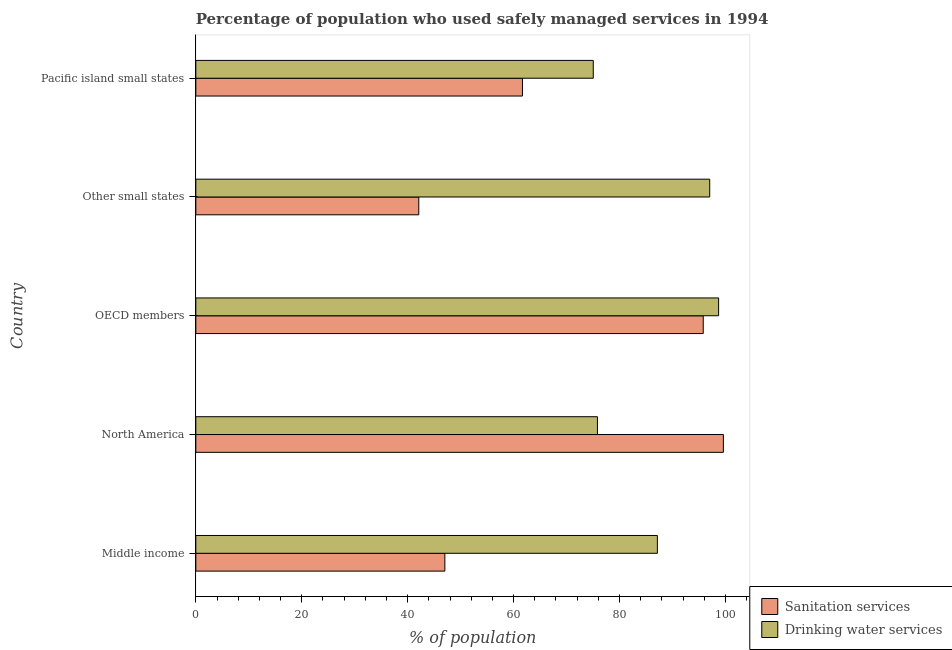How many different coloured bars are there?
Offer a very short reply. 2. How many groups of bars are there?
Your answer should be compact. 5. How many bars are there on the 2nd tick from the top?
Provide a short and direct response. 2. How many bars are there on the 3rd tick from the bottom?
Give a very brief answer. 2. What is the label of the 4th group of bars from the top?
Your response must be concise. North America. What is the percentage of population who used sanitation services in Middle income?
Your response must be concise. 47.03. Across all countries, what is the maximum percentage of population who used drinking water services?
Offer a terse response. 98.72. Across all countries, what is the minimum percentage of population who used drinking water services?
Keep it short and to the point. 75.05. In which country was the percentage of population who used drinking water services maximum?
Your answer should be compact. OECD members. In which country was the percentage of population who used drinking water services minimum?
Your answer should be compact. Pacific island small states. What is the total percentage of population who used drinking water services in the graph?
Ensure brevity in your answer.  433.8. What is the difference between the percentage of population who used drinking water services in North America and that in Other small states?
Your answer should be compact. -21.2. What is the difference between the percentage of population who used sanitation services in Middle income and the percentage of population who used drinking water services in North America?
Keep it short and to the point. -28.81. What is the average percentage of population who used drinking water services per country?
Provide a short and direct response. 86.76. What is the difference between the percentage of population who used sanitation services and percentage of population who used drinking water services in Pacific island small states?
Provide a short and direct response. -13.37. In how many countries, is the percentage of population who used drinking water services greater than 64 %?
Keep it short and to the point. 5. What is the ratio of the percentage of population who used sanitation services in Middle income to that in OECD members?
Your response must be concise. 0.49. What is the difference between the highest and the second highest percentage of population who used drinking water services?
Ensure brevity in your answer.  1.68. What is the difference between the highest and the lowest percentage of population who used sanitation services?
Your answer should be very brief. 57.52. In how many countries, is the percentage of population who used drinking water services greater than the average percentage of population who used drinking water services taken over all countries?
Your answer should be very brief. 3. What does the 1st bar from the top in OECD members represents?
Keep it short and to the point. Drinking water services. What does the 1st bar from the bottom in Middle income represents?
Give a very brief answer. Sanitation services. How many countries are there in the graph?
Give a very brief answer. 5. What is the difference between two consecutive major ticks on the X-axis?
Provide a succinct answer. 20. Are the values on the major ticks of X-axis written in scientific E-notation?
Your answer should be very brief. No. Does the graph contain any zero values?
Give a very brief answer. No. Does the graph contain grids?
Your response must be concise. No. Where does the legend appear in the graph?
Provide a short and direct response. Bottom right. How many legend labels are there?
Give a very brief answer. 2. What is the title of the graph?
Your answer should be compact. Percentage of population who used safely managed services in 1994. Does "Female" appear as one of the legend labels in the graph?
Your answer should be very brief. No. What is the label or title of the X-axis?
Provide a succinct answer. % of population. What is the label or title of the Y-axis?
Your answer should be very brief. Country. What is the % of population of Sanitation services in Middle income?
Your answer should be compact. 47.03. What is the % of population in Drinking water services in Middle income?
Keep it short and to the point. 87.16. What is the % of population in Sanitation services in North America?
Provide a succinct answer. 99.62. What is the % of population in Drinking water services in North America?
Your answer should be compact. 75.84. What is the % of population in Sanitation services in OECD members?
Provide a short and direct response. 95.82. What is the % of population of Drinking water services in OECD members?
Give a very brief answer. 98.72. What is the % of population of Sanitation services in Other small states?
Your answer should be compact. 42.1. What is the % of population of Drinking water services in Other small states?
Your response must be concise. 97.04. What is the % of population in Sanitation services in Pacific island small states?
Give a very brief answer. 61.68. What is the % of population of Drinking water services in Pacific island small states?
Your answer should be compact. 75.05. Across all countries, what is the maximum % of population in Sanitation services?
Give a very brief answer. 99.62. Across all countries, what is the maximum % of population of Drinking water services?
Offer a very short reply. 98.72. Across all countries, what is the minimum % of population of Sanitation services?
Ensure brevity in your answer.  42.1. Across all countries, what is the minimum % of population in Drinking water services?
Make the answer very short. 75.05. What is the total % of population of Sanitation services in the graph?
Provide a succinct answer. 346.24. What is the total % of population in Drinking water services in the graph?
Provide a short and direct response. 433.8. What is the difference between the % of population in Sanitation services in Middle income and that in North America?
Your answer should be compact. -52.59. What is the difference between the % of population of Drinking water services in Middle income and that in North America?
Your response must be concise. 11.32. What is the difference between the % of population in Sanitation services in Middle income and that in OECD members?
Give a very brief answer. -48.79. What is the difference between the % of population in Drinking water services in Middle income and that in OECD members?
Your answer should be compact. -11.56. What is the difference between the % of population of Sanitation services in Middle income and that in Other small states?
Keep it short and to the point. 4.93. What is the difference between the % of population in Drinking water services in Middle income and that in Other small states?
Your answer should be very brief. -9.88. What is the difference between the % of population in Sanitation services in Middle income and that in Pacific island small states?
Make the answer very short. -14.65. What is the difference between the % of population of Drinking water services in Middle income and that in Pacific island small states?
Make the answer very short. 12.11. What is the difference between the % of population in Sanitation services in North America and that in OECD members?
Give a very brief answer. 3.8. What is the difference between the % of population in Drinking water services in North America and that in OECD members?
Make the answer very short. -22.88. What is the difference between the % of population of Sanitation services in North America and that in Other small states?
Make the answer very short. 57.52. What is the difference between the % of population in Drinking water services in North America and that in Other small states?
Offer a terse response. -21.2. What is the difference between the % of population in Sanitation services in North America and that in Pacific island small states?
Make the answer very short. 37.94. What is the difference between the % of population of Drinking water services in North America and that in Pacific island small states?
Your response must be concise. 0.79. What is the difference between the % of population in Sanitation services in OECD members and that in Other small states?
Offer a terse response. 53.72. What is the difference between the % of population of Drinking water services in OECD members and that in Other small states?
Keep it short and to the point. 1.68. What is the difference between the % of population in Sanitation services in OECD members and that in Pacific island small states?
Your answer should be very brief. 34.14. What is the difference between the % of population in Drinking water services in OECD members and that in Pacific island small states?
Keep it short and to the point. 23.67. What is the difference between the % of population of Sanitation services in Other small states and that in Pacific island small states?
Ensure brevity in your answer.  -19.58. What is the difference between the % of population in Drinking water services in Other small states and that in Pacific island small states?
Your response must be concise. 21.99. What is the difference between the % of population of Sanitation services in Middle income and the % of population of Drinking water services in North America?
Your answer should be very brief. -28.81. What is the difference between the % of population of Sanitation services in Middle income and the % of population of Drinking water services in OECD members?
Your answer should be compact. -51.69. What is the difference between the % of population of Sanitation services in Middle income and the % of population of Drinking water services in Other small states?
Your response must be concise. -50.01. What is the difference between the % of population of Sanitation services in Middle income and the % of population of Drinking water services in Pacific island small states?
Give a very brief answer. -28.02. What is the difference between the % of population in Sanitation services in North America and the % of population in Drinking water services in OECD members?
Your response must be concise. 0.9. What is the difference between the % of population in Sanitation services in North America and the % of population in Drinking water services in Other small states?
Keep it short and to the point. 2.58. What is the difference between the % of population of Sanitation services in North America and the % of population of Drinking water services in Pacific island small states?
Offer a terse response. 24.57. What is the difference between the % of population in Sanitation services in OECD members and the % of population in Drinking water services in Other small states?
Give a very brief answer. -1.22. What is the difference between the % of population of Sanitation services in OECD members and the % of population of Drinking water services in Pacific island small states?
Offer a terse response. 20.77. What is the difference between the % of population of Sanitation services in Other small states and the % of population of Drinking water services in Pacific island small states?
Your answer should be compact. -32.95. What is the average % of population in Sanitation services per country?
Your response must be concise. 69.25. What is the average % of population in Drinking water services per country?
Your answer should be compact. 86.76. What is the difference between the % of population of Sanitation services and % of population of Drinking water services in Middle income?
Offer a very short reply. -40.13. What is the difference between the % of population in Sanitation services and % of population in Drinking water services in North America?
Provide a succinct answer. 23.78. What is the difference between the % of population in Sanitation services and % of population in Drinking water services in OECD members?
Make the answer very short. -2.9. What is the difference between the % of population in Sanitation services and % of population in Drinking water services in Other small states?
Offer a very short reply. -54.94. What is the difference between the % of population of Sanitation services and % of population of Drinking water services in Pacific island small states?
Your answer should be compact. -13.37. What is the ratio of the % of population of Sanitation services in Middle income to that in North America?
Your answer should be compact. 0.47. What is the ratio of the % of population of Drinking water services in Middle income to that in North America?
Keep it short and to the point. 1.15. What is the ratio of the % of population of Sanitation services in Middle income to that in OECD members?
Your response must be concise. 0.49. What is the ratio of the % of population in Drinking water services in Middle income to that in OECD members?
Your answer should be very brief. 0.88. What is the ratio of the % of population of Sanitation services in Middle income to that in Other small states?
Your response must be concise. 1.12. What is the ratio of the % of population of Drinking water services in Middle income to that in Other small states?
Provide a succinct answer. 0.9. What is the ratio of the % of population in Sanitation services in Middle income to that in Pacific island small states?
Your answer should be very brief. 0.76. What is the ratio of the % of population of Drinking water services in Middle income to that in Pacific island small states?
Provide a succinct answer. 1.16. What is the ratio of the % of population in Sanitation services in North America to that in OECD members?
Offer a very short reply. 1.04. What is the ratio of the % of population of Drinking water services in North America to that in OECD members?
Your answer should be compact. 0.77. What is the ratio of the % of population of Sanitation services in North America to that in Other small states?
Keep it short and to the point. 2.37. What is the ratio of the % of population of Drinking water services in North America to that in Other small states?
Keep it short and to the point. 0.78. What is the ratio of the % of population of Sanitation services in North America to that in Pacific island small states?
Provide a short and direct response. 1.62. What is the ratio of the % of population in Drinking water services in North America to that in Pacific island small states?
Keep it short and to the point. 1.01. What is the ratio of the % of population in Sanitation services in OECD members to that in Other small states?
Your answer should be very brief. 2.28. What is the ratio of the % of population of Drinking water services in OECD members to that in Other small states?
Your answer should be compact. 1.02. What is the ratio of the % of population of Sanitation services in OECD members to that in Pacific island small states?
Offer a very short reply. 1.55. What is the ratio of the % of population of Drinking water services in OECD members to that in Pacific island small states?
Your answer should be compact. 1.32. What is the ratio of the % of population of Sanitation services in Other small states to that in Pacific island small states?
Your answer should be very brief. 0.68. What is the ratio of the % of population in Drinking water services in Other small states to that in Pacific island small states?
Your answer should be compact. 1.29. What is the difference between the highest and the second highest % of population of Sanitation services?
Make the answer very short. 3.8. What is the difference between the highest and the second highest % of population of Drinking water services?
Offer a terse response. 1.68. What is the difference between the highest and the lowest % of population of Sanitation services?
Offer a very short reply. 57.52. What is the difference between the highest and the lowest % of population of Drinking water services?
Your answer should be compact. 23.67. 